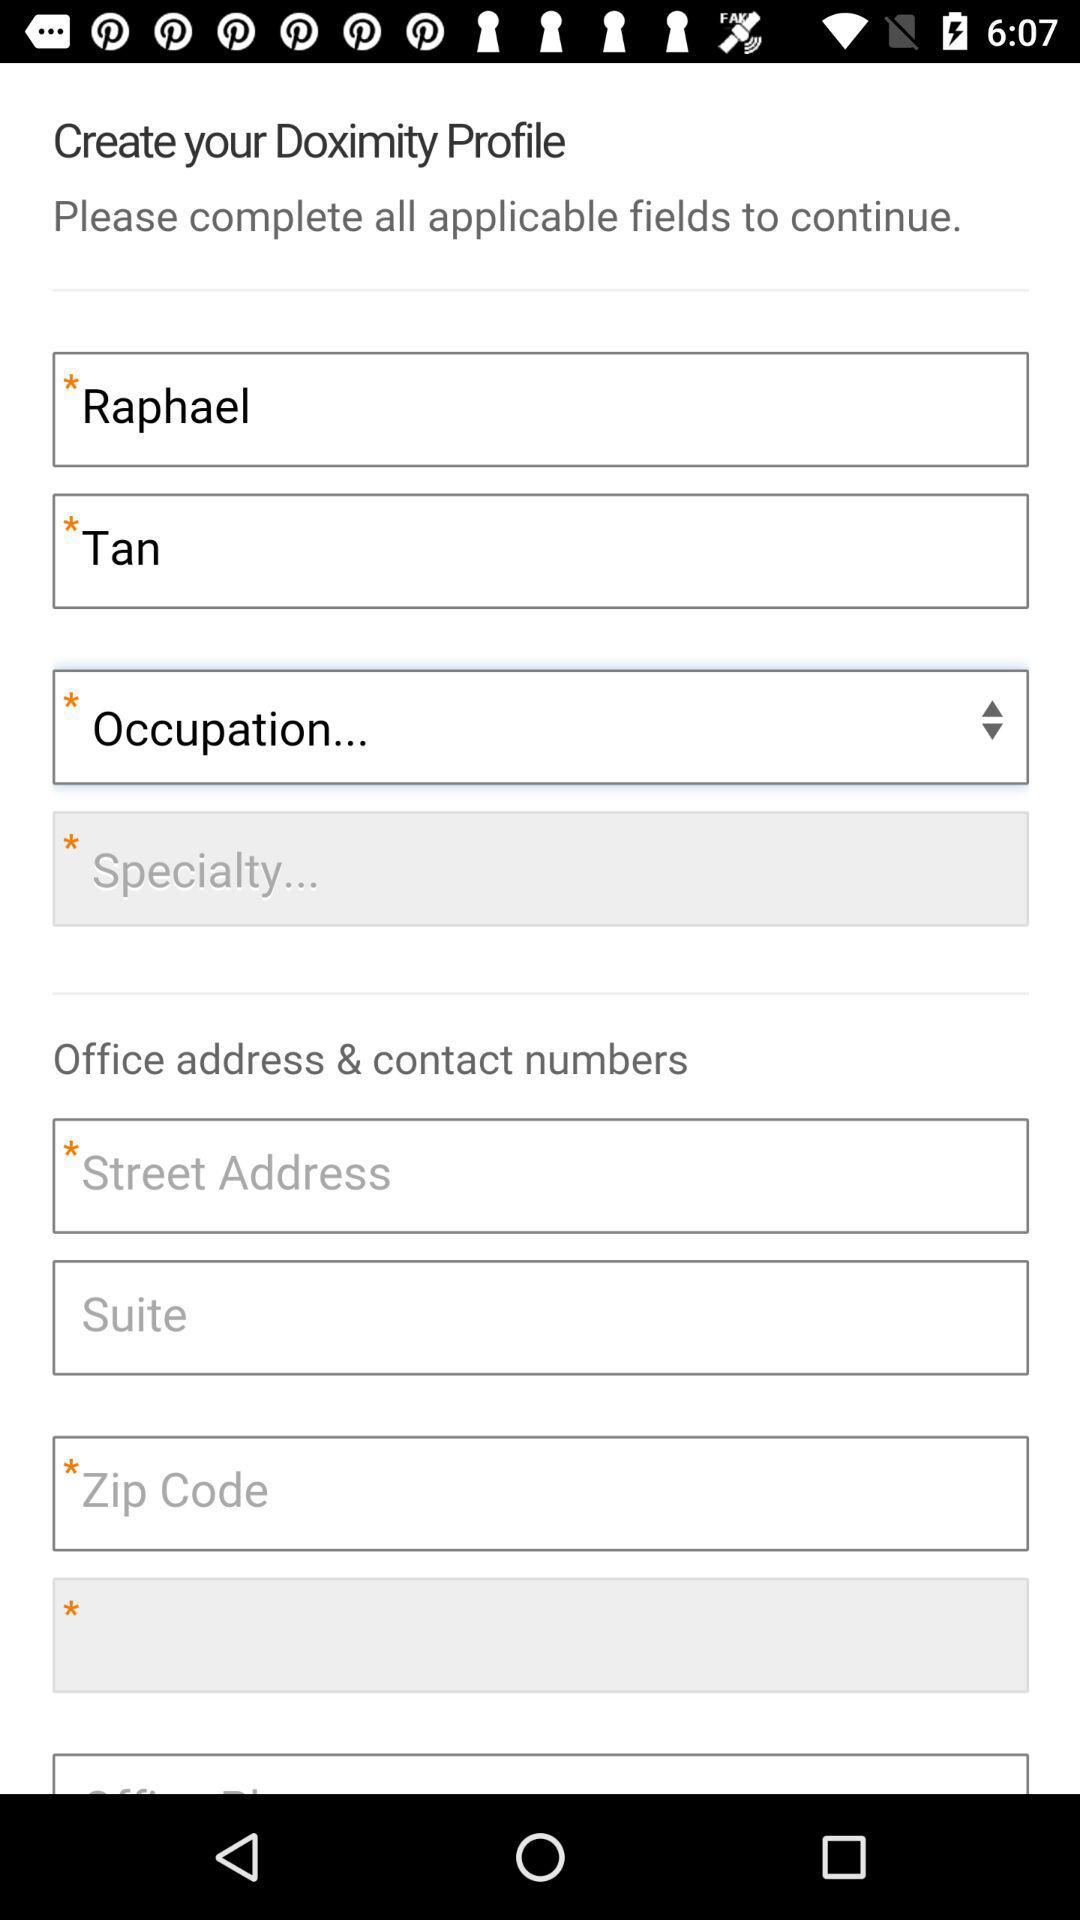What is the last name? The last name is Tan. 